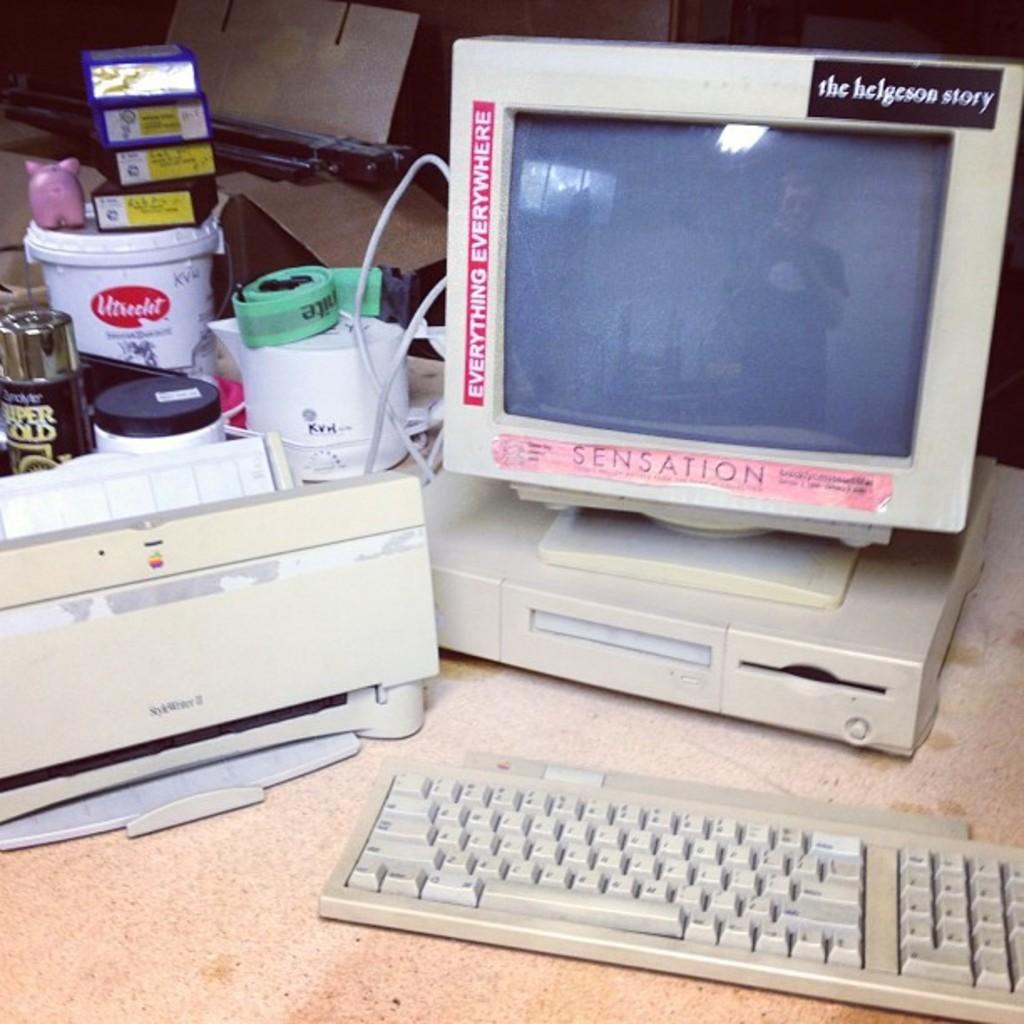Is sensation the computer or just a sticker?
Ensure brevity in your answer.  Sticker. What kind of story?
Your response must be concise. Helgeson. 